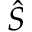Convert formula to latex. <formula><loc_0><loc_0><loc_500><loc_500>\hat { S }</formula> 